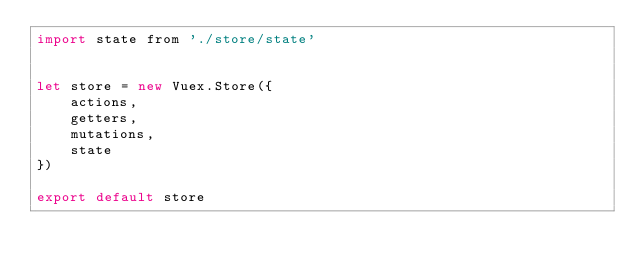<code> <loc_0><loc_0><loc_500><loc_500><_JavaScript_>import state from './store/state'


let store = new Vuex.Store({
    actions,
    getters,
    mutations,
    state
})

export default store</code> 